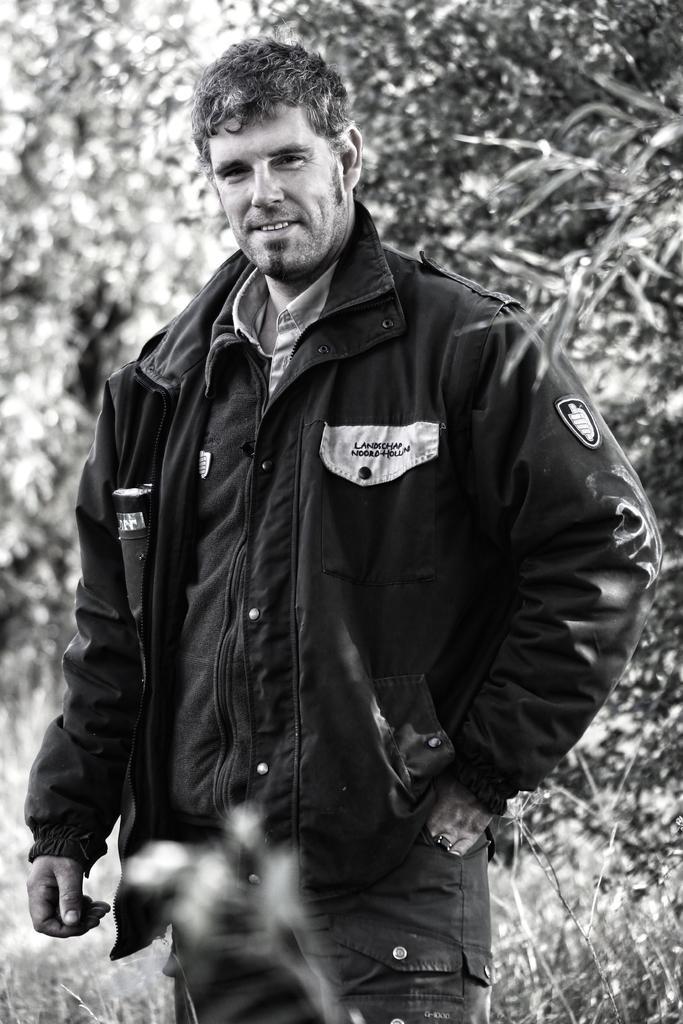How would you summarize this image in a sentence or two? This picture is in black and white. In the center, there is a man wearing a jacket and a jeans. In the background there are trees. 